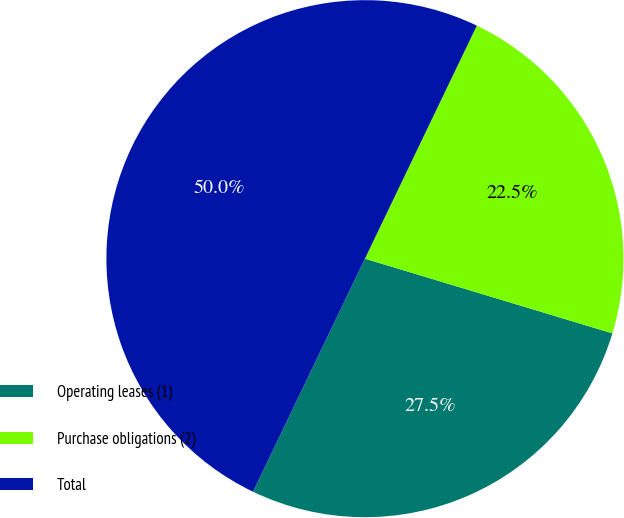Convert chart. <chart><loc_0><loc_0><loc_500><loc_500><pie_chart><fcel>Operating leases (1)<fcel>Purchase obligations (2)<fcel>Total<nl><fcel>27.46%<fcel>22.54%<fcel>50.0%<nl></chart> 